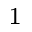Convert formula to latex. <formula><loc_0><loc_0><loc_500><loc_500>^ { 1 }</formula> 